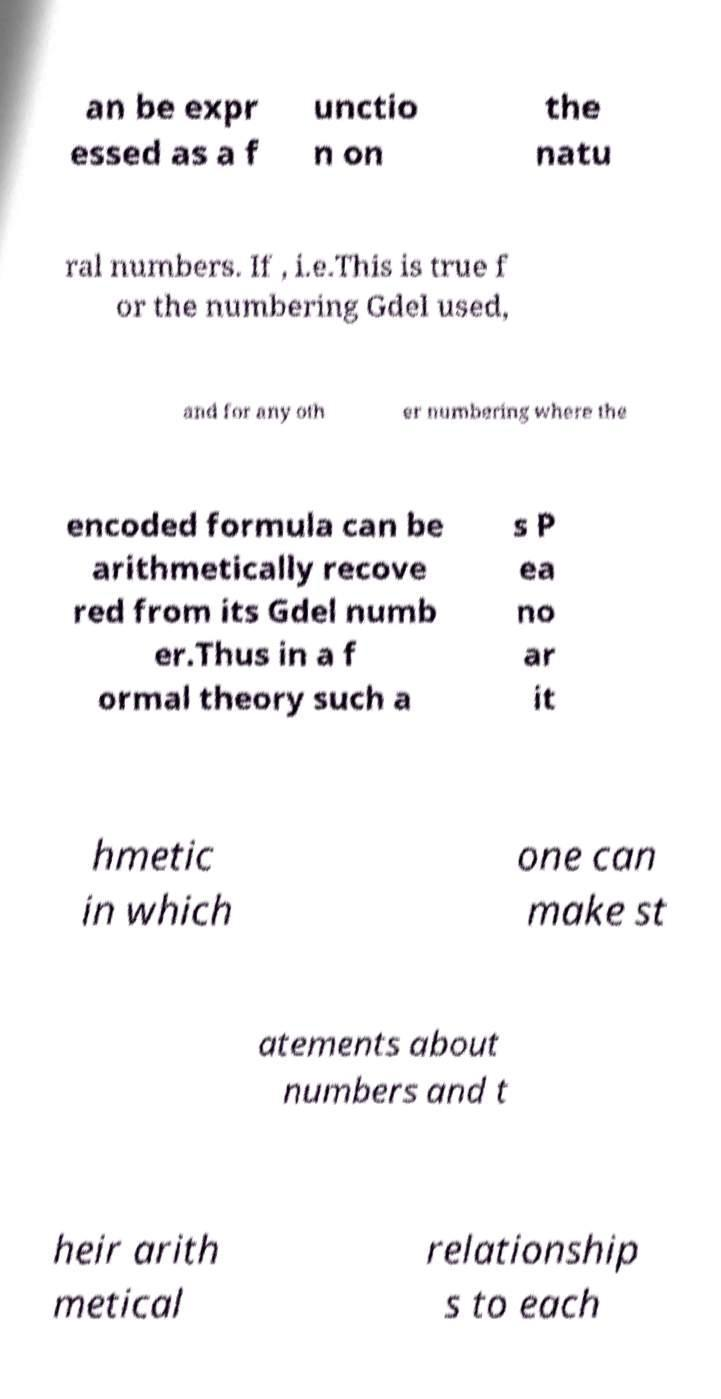Please identify and transcribe the text found in this image. an be expr essed as a f unctio n on the natu ral numbers. If , i.e.This is true f or the numbering Gdel used, and for any oth er numbering where the encoded formula can be arithmetically recove red from its Gdel numb er.Thus in a f ormal theory such a s P ea no ar it hmetic in which one can make st atements about numbers and t heir arith metical relationship s to each 